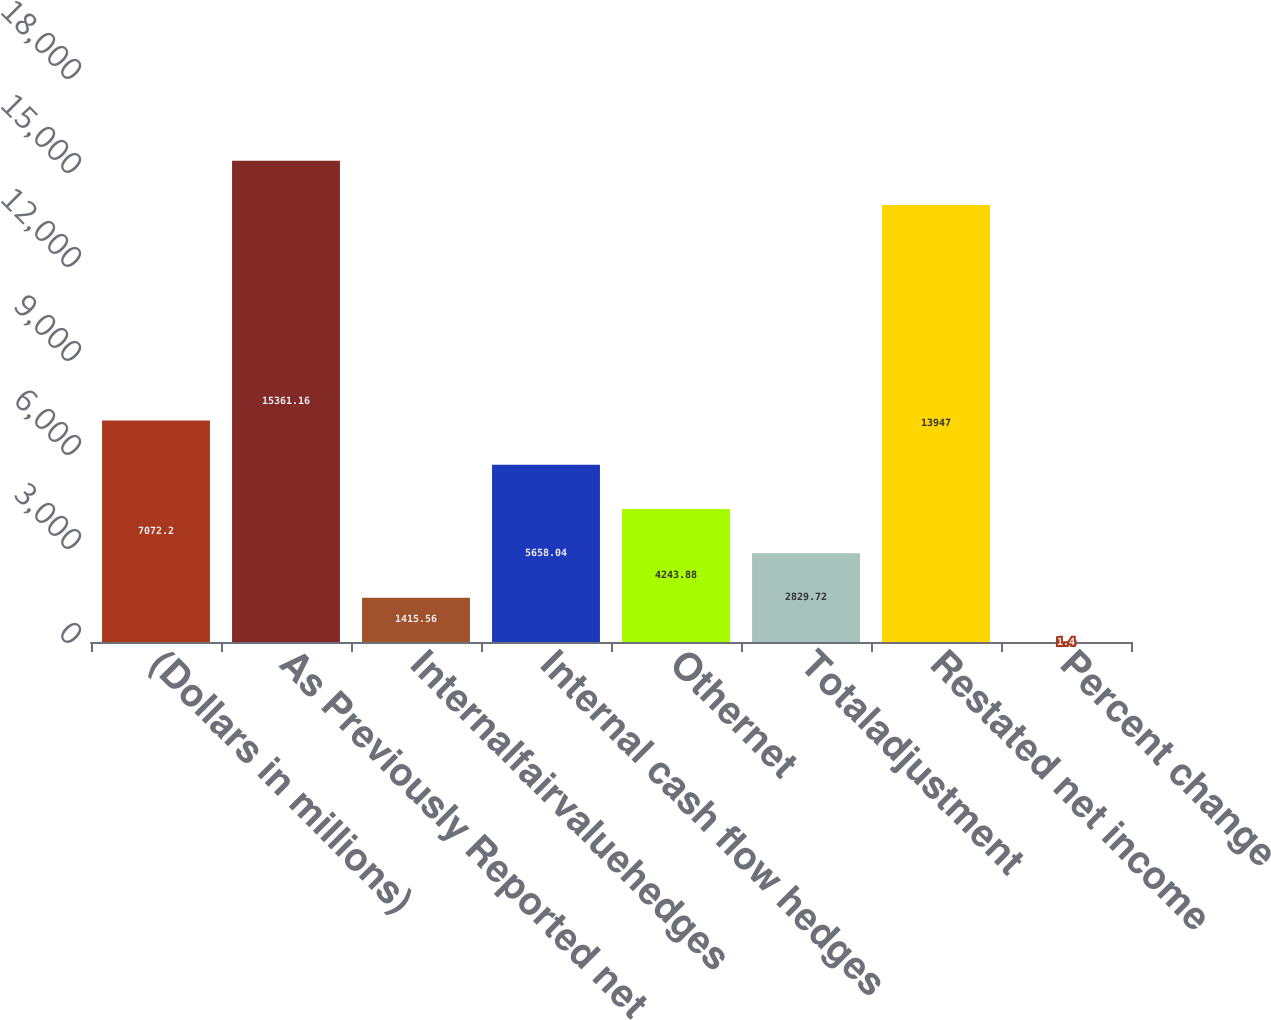Convert chart. <chart><loc_0><loc_0><loc_500><loc_500><bar_chart><fcel>(Dollars in millions)<fcel>As Previously Reported net<fcel>Internalfairvaluehedges<fcel>Internal cash flow hedges<fcel>Othernet<fcel>Totaladjustment<fcel>Restated net income<fcel>Percent change<nl><fcel>7072.2<fcel>15361.2<fcel>1415.56<fcel>5658.04<fcel>4243.88<fcel>2829.72<fcel>13947<fcel>1.4<nl></chart> 